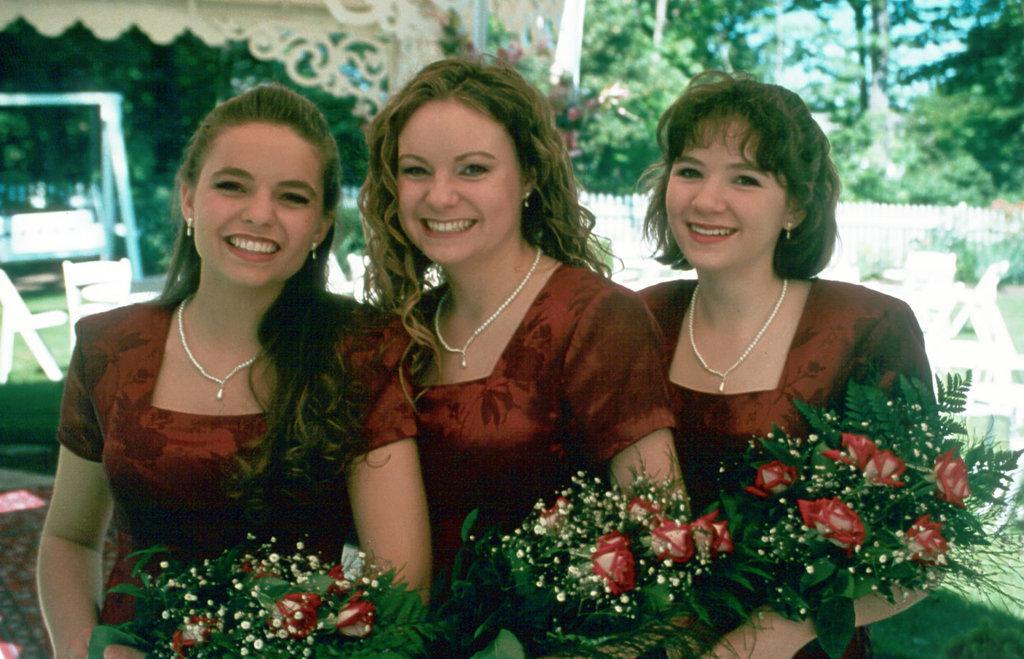Describe this image in one or two sentences. In this image we can see three women. They are smiling and holding flower bouquets. In the background we can see chairs, fence, plants, trees, and objects. 